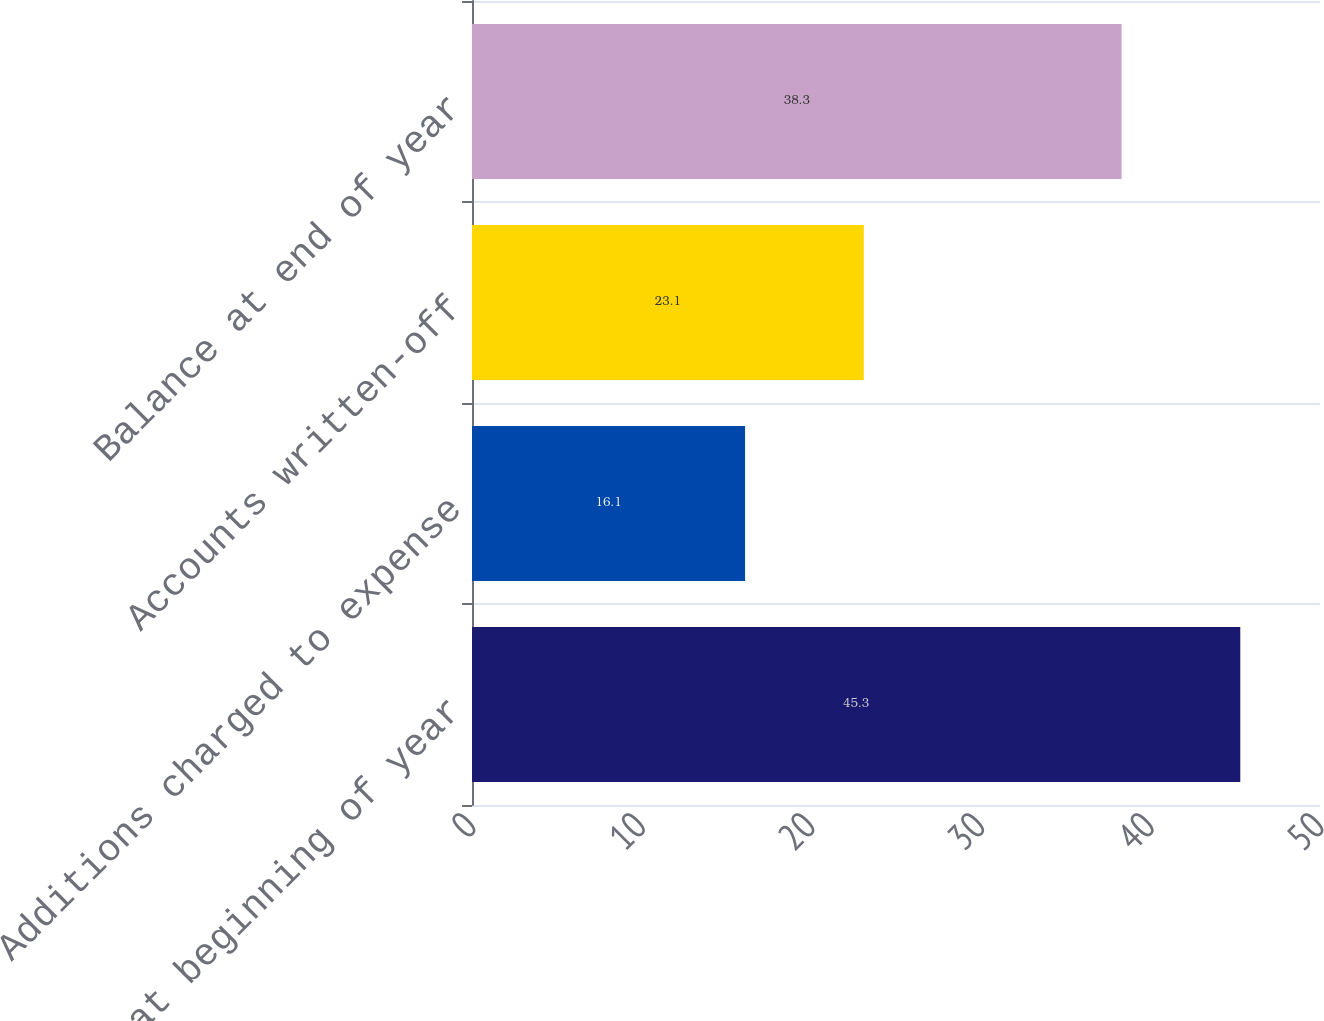Convert chart to OTSL. <chart><loc_0><loc_0><loc_500><loc_500><bar_chart><fcel>Balance at beginning of year<fcel>Additions charged to expense<fcel>Accounts written-off<fcel>Balance at end of year<nl><fcel>45.3<fcel>16.1<fcel>23.1<fcel>38.3<nl></chart> 